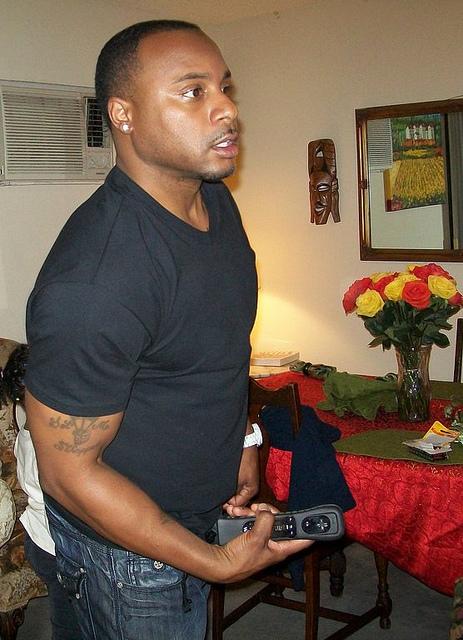Is he having a conversation?
Quick response, please. No. What is on the man's bicep?
Answer briefly. Tattoo. Are the flowers in the vase roses or tulips?
Answer briefly. Roses. What are the people doing?
Write a very short answer. Playing. What is he holding in his hands?
Keep it brief. Remote. What is there in his hand?
Write a very short answer. Remote. 